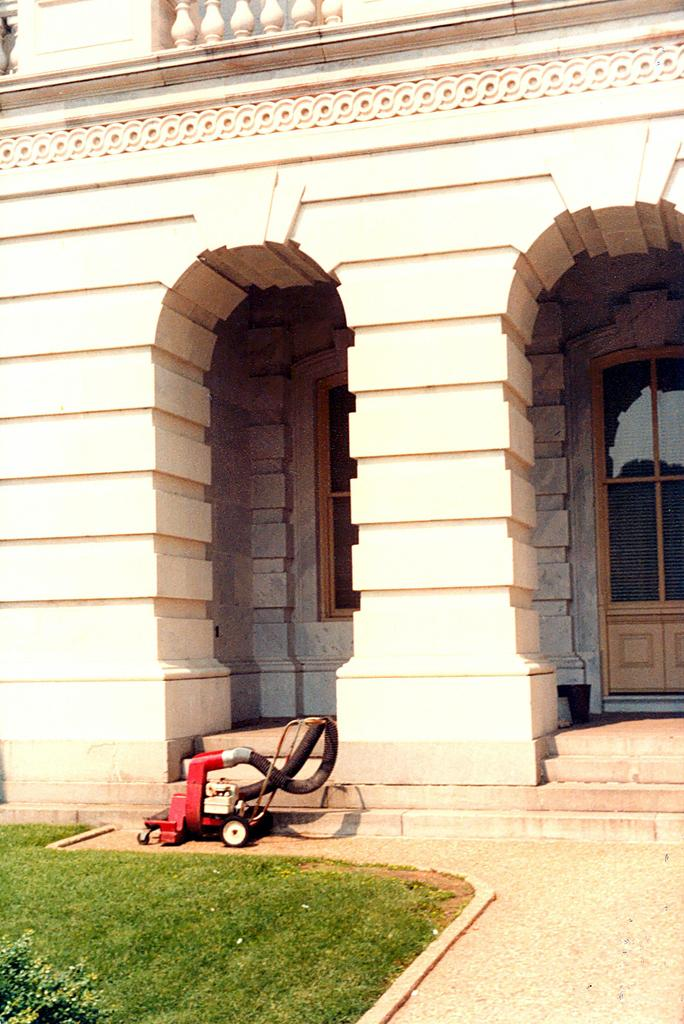What type of vegetation is visible in the image? There is grass in the image. What kind of feature allows for walking or passage in the image? There is a path and steps in the image. What type of structure is present in the image? There is a building in the image. What architectural element is visible in the building? There is a window in the image. What part of the building can be used for entering or exiting? There are doors in the image. Can you describe the unspecified object in the image? Unfortunately, the facts provided do not give any details about the unspecified object. What type of teaching method is being demonstrated through the window in the image? There is no teaching method visible through the window in the image. What kind of pancake is being served on the steps in the image? There is no pancake present in the image. 